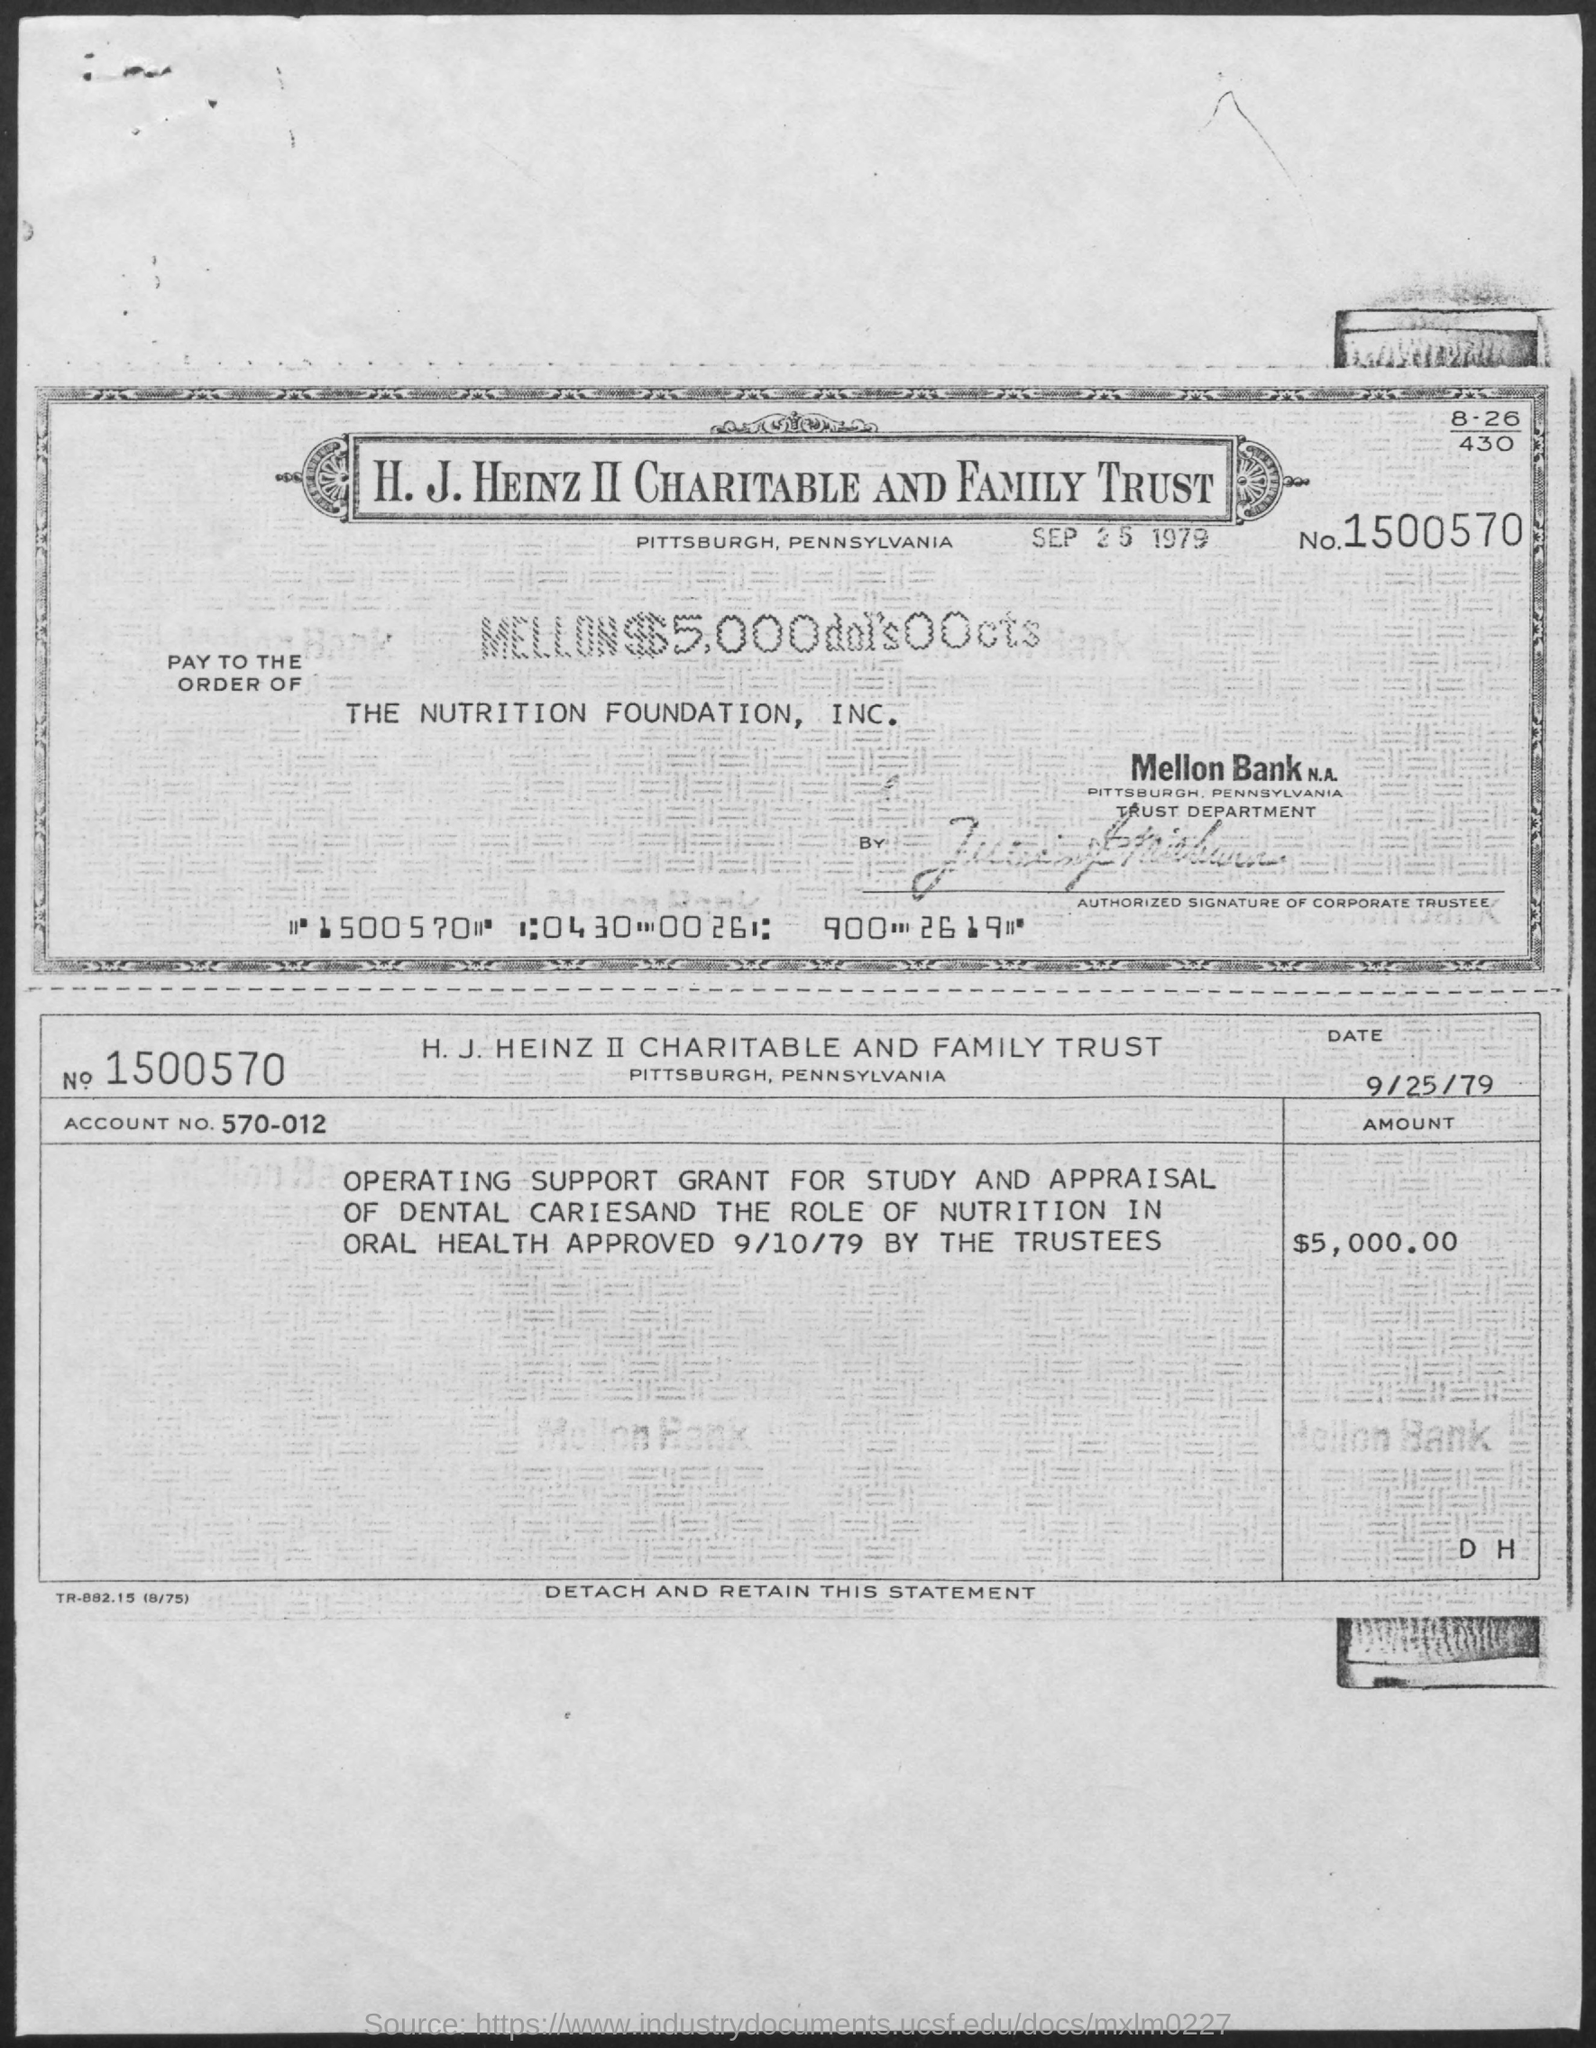Mention the date given below  "H.J. HEINZ II CHARITABLE AND FAMILY TRUST"?
Provide a succinct answer. SEP 25 1979. Mention the "ACCOUNT NO." given?
Provide a short and direct response. 570-012. What is the "AMOUNT" mentioned?
Provide a succinct answer. 5,000.00. $5,000 is paid to which FOUNDATION?
Keep it short and to the point. THE NUTRITION FOUNDATION,  INC. Where is "H.J. HEINZ II CHARITABLE AND FAMILY TRUST" located?
Ensure brevity in your answer.  Pittsburgh, Pennsylvania. 